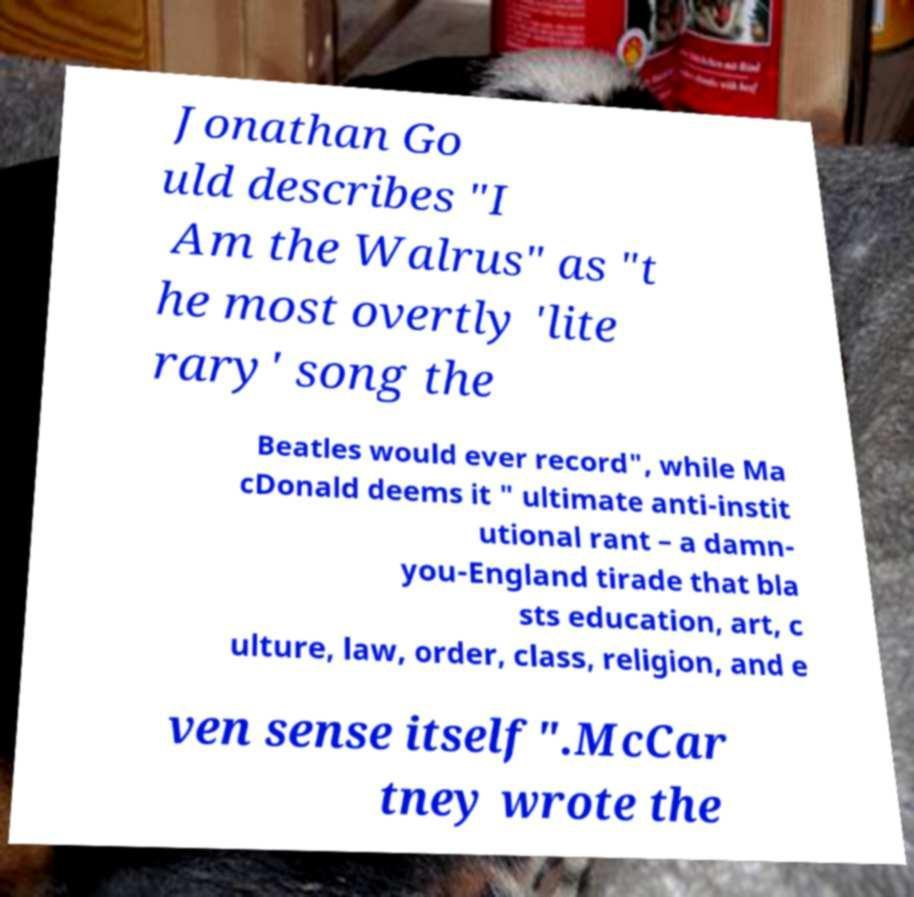Can you read and provide the text displayed in the image?This photo seems to have some interesting text. Can you extract and type it out for me? Jonathan Go uld describes "I Am the Walrus" as "t he most overtly 'lite rary' song the Beatles would ever record", while Ma cDonald deems it " ultimate anti-instit utional rant – a damn- you-England tirade that bla sts education, art, c ulture, law, order, class, religion, and e ven sense itself".McCar tney wrote the 